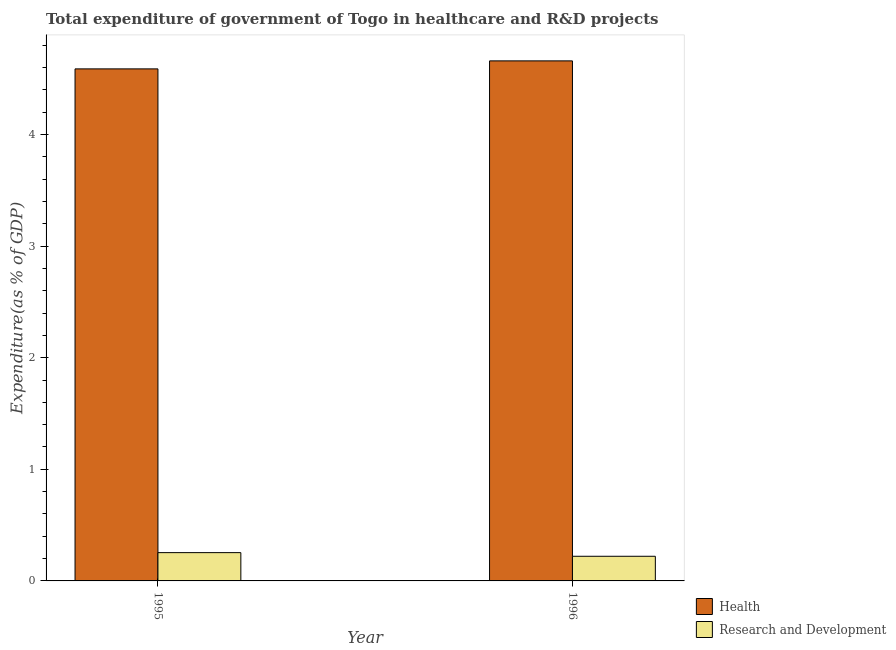How many different coloured bars are there?
Keep it short and to the point. 2. How many bars are there on the 1st tick from the left?
Your response must be concise. 2. In how many cases, is the number of bars for a given year not equal to the number of legend labels?
Provide a succinct answer. 0. What is the expenditure in healthcare in 1995?
Offer a very short reply. 4.59. Across all years, what is the maximum expenditure in r&d?
Your answer should be compact. 0.25. Across all years, what is the minimum expenditure in healthcare?
Your response must be concise. 4.59. In which year was the expenditure in r&d maximum?
Your response must be concise. 1995. What is the total expenditure in r&d in the graph?
Give a very brief answer. 0.47. What is the difference between the expenditure in r&d in 1995 and that in 1996?
Offer a very short reply. 0.03. What is the difference between the expenditure in r&d in 1995 and the expenditure in healthcare in 1996?
Your answer should be very brief. 0.03. What is the average expenditure in r&d per year?
Your answer should be compact. 0.24. What is the ratio of the expenditure in healthcare in 1995 to that in 1996?
Provide a short and direct response. 0.98. Is the expenditure in healthcare in 1995 less than that in 1996?
Keep it short and to the point. Yes. What does the 2nd bar from the left in 1996 represents?
Make the answer very short. Research and Development. What does the 2nd bar from the right in 1995 represents?
Your answer should be compact. Health. Are all the bars in the graph horizontal?
Give a very brief answer. No. How many years are there in the graph?
Provide a succinct answer. 2. Does the graph contain any zero values?
Your response must be concise. No. Does the graph contain grids?
Offer a very short reply. No. Where does the legend appear in the graph?
Offer a very short reply. Bottom right. How are the legend labels stacked?
Your answer should be very brief. Vertical. What is the title of the graph?
Give a very brief answer. Total expenditure of government of Togo in healthcare and R&D projects. What is the label or title of the Y-axis?
Your answer should be compact. Expenditure(as % of GDP). What is the Expenditure(as % of GDP) of Health in 1995?
Your response must be concise. 4.59. What is the Expenditure(as % of GDP) in Research and Development in 1995?
Give a very brief answer. 0.25. What is the Expenditure(as % of GDP) in Health in 1996?
Keep it short and to the point. 4.66. What is the Expenditure(as % of GDP) of Research and Development in 1996?
Your response must be concise. 0.22. Across all years, what is the maximum Expenditure(as % of GDP) in Health?
Give a very brief answer. 4.66. Across all years, what is the maximum Expenditure(as % of GDP) in Research and Development?
Your answer should be compact. 0.25. Across all years, what is the minimum Expenditure(as % of GDP) in Health?
Provide a short and direct response. 4.59. Across all years, what is the minimum Expenditure(as % of GDP) in Research and Development?
Your answer should be very brief. 0.22. What is the total Expenditure(as % of GDP) of Health in the graph?
Ensure brevity in your answer.  9.25. What is the total Expenditure(as % of GDP) of Research and Development in the graph?
Your answer should be very brief. 0.47. What is the difference between the Expenditure(as % of GDP) in Health in 1995 and that in 1996?
Make the answer very short. -0.07. What is the difference between the Expenditure(as % of GDP) of Research and Development in 1995 and that in 1996?
Offer a very short reply. 0.03. What is the difference between the Expenditure(as % of GDP) of Health in 1995 and the Expenditure(as % of GDP) of Research and Development in 1996?
Your response must be concise. 4.37. What is the average Expenditure(as % of GDP) in Health per year?
Give a very brief answer. 4.62. What is the average Expenditure(as % of GDP) of Research and Development per year?
Your response must be concise. 0.24. In the year 1995, what is the difference between the Expenditure(as % of GDP) of Health and Expenditure(as % of GDP) of Research and Development?
Provide a short and direct response. 4.33. In the year 1996, what is the difference between the Expenditure(as % of GDP) of Health and Expenditure(as % of GDP) of Research and Development?
Your answer should be very brief. 4.44. What is the ratio of the Expenditure(as % of GDP) in Health in 1995 to that in 1996?
Your answer should be compact. 0.98. What is the ratio of the Expenditure(as % of GDP) in Research and Development in 1995 to that in 1996?
Offer a very short reply. 1.15. What is the difference between the highest and the second highest Expenditure(as % of GDP) of Health?
Your response must be concise. 0.07. What is the difference between the highest and the second highest Expenditure(as % of GDP) of Research and Development?
Your response must be concise. 0.03. What is the difference between the highest and the lowest Expenditure(as % of GDP) of Health?
Make the answer very short. 0.07. What is the difference between the highest and the lowest Expenditure(as % of GDP) in Research and Development?
Your answer should be compact. 0.03. 